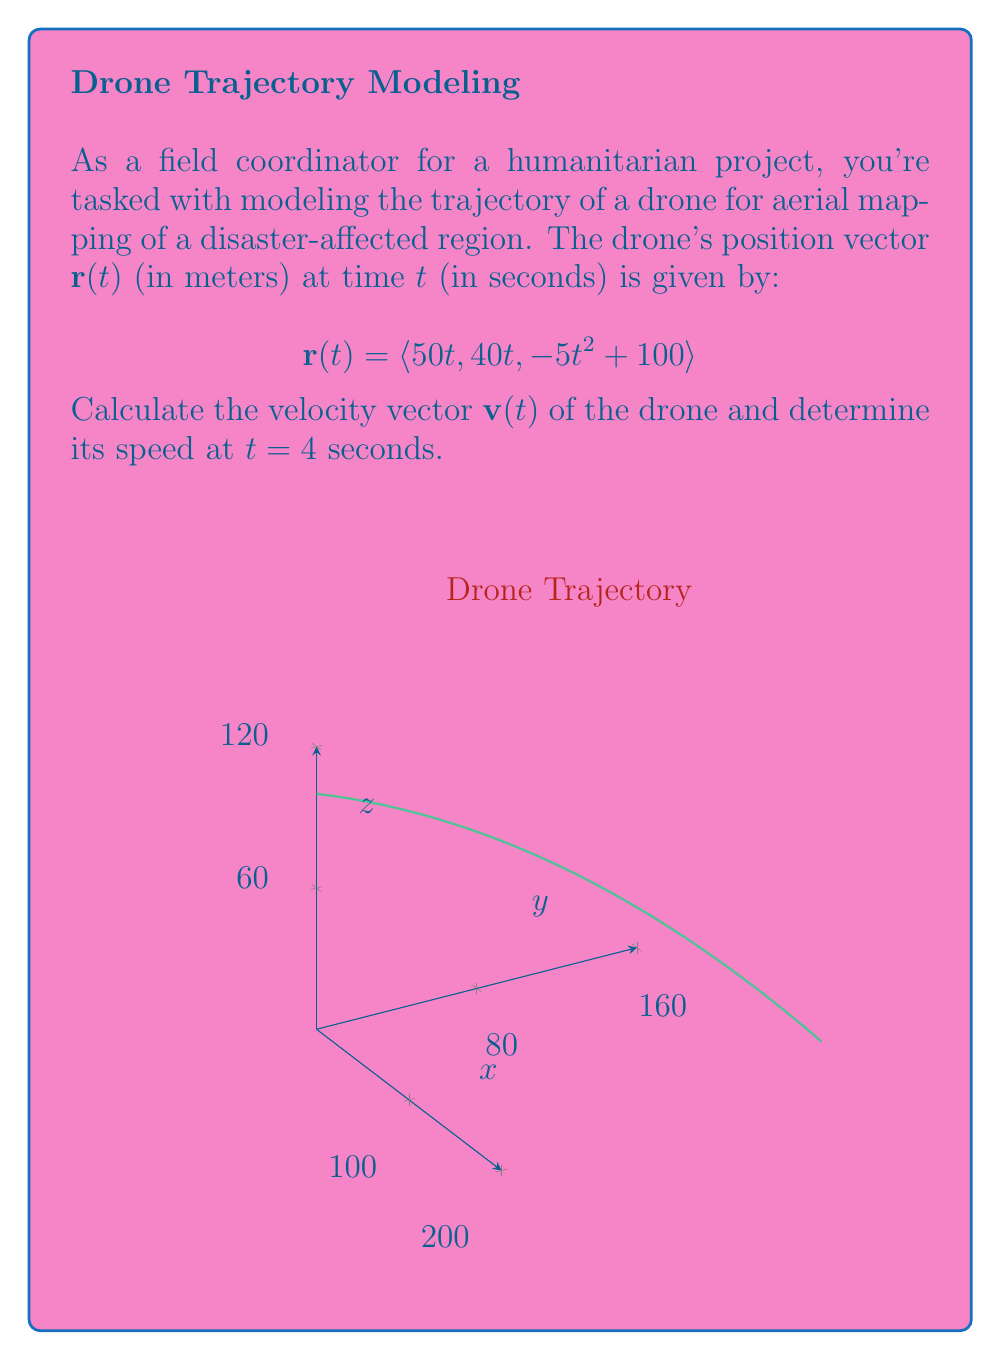Can you solve this math problem? To solve this problem, we'll follow these steps:

1) First, let's find the velocity vector $\mathbf{v}(t)$. The velocity is the derivative of the position vector with respect to time:

   $$\mathbf{v}(t) = \frac{d}{dt}\mathbf{r}(t) = \left\langle \frac{d}{dt}(50t), \frac{d}{dt}(40t), \frac{d}{dt}(-5t^2 + 100) \right\rangle$$

2) Calculating each component:
   
   $$\mathbf{v}(t) = \langle 50, 40, -10t \rangle$$

3) Now that we have the velocity vector, we need to find its magnitude (speed) at $t = 4$ seconds. Let's call this $\mathbf{v}(4)$:

   $$\mathbf{v}(4) = \langle 50, 40, -10(4) \rangle = \langle 50, 40, -40 \rangle$$

4) The speed is the magnitude of the velocity vector. We can calculate this using the Pythagorean theorem in 3D:

   $$\text{speed} = \|\mathbf{v}(4)\| = \sqrt{50^2 + 40^2 + (-40)^2}$$

5) Simplifying:
   
   $$\text{speed} = \sqrt{2500 + 1600 + 1600} = \sqrt{5700} = 30\sqrt{19} \approx 75.50 \text{ m/s}$$

Thus, the speed of the drone at $t = 4$ seconds is $30\sqrt{19}$ m/s.
Answer: $30\sqrt{19}$ m/s 